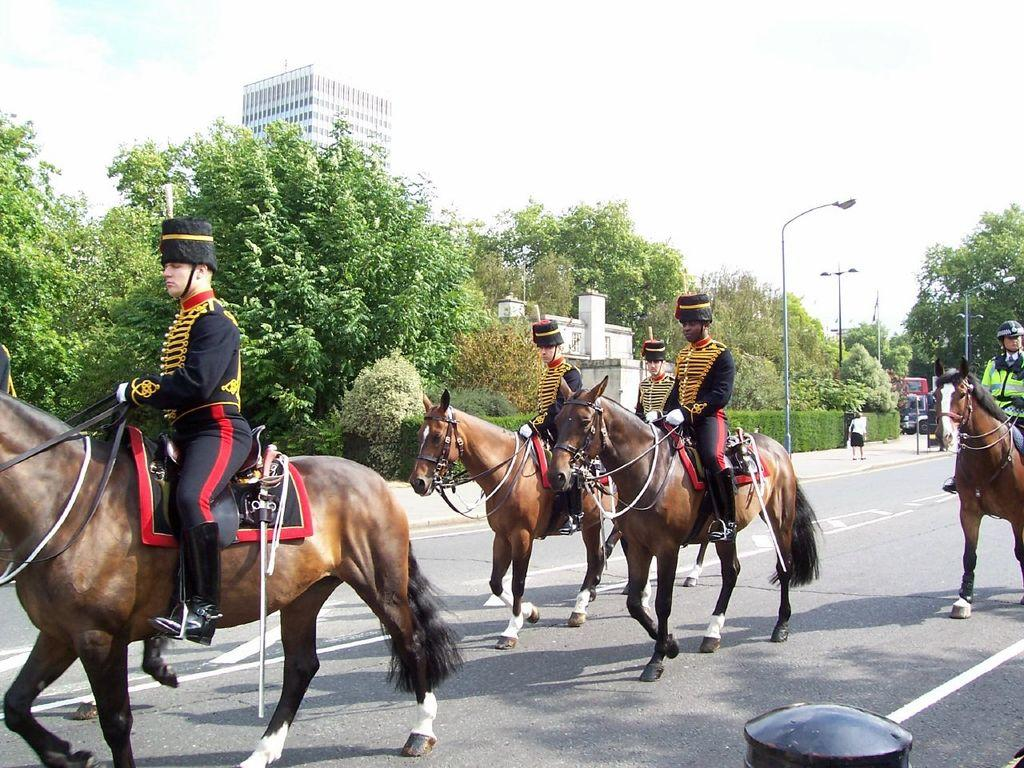What are the persons in the image wearing? The persons in the image are wearing black security dress. What are the persons doing in the image? The persons are riding horses on the road. What can be seen in the background of the image? There are trees and a building visible in the background of the image. What is visible above the building in the image? The sky is visible above the building in the image. Can you see any fairies flying around the persons riding horses in the image? No, there are no fairies visible in the image. What type of bun is being served at the event in the image? There is no event or bun present in the image; it features persons in black security dress riding horses on the road. 